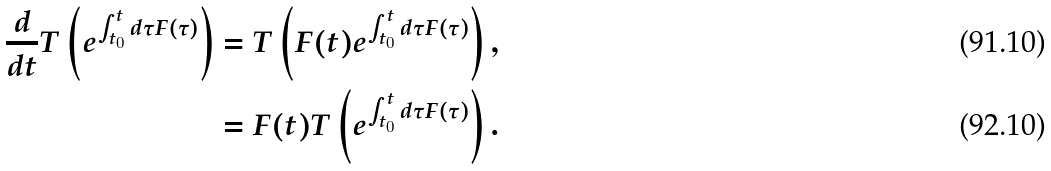Convert formula to latex. <formula><loc_0><loc_0><loc_500><loc_500>\frac { d } { d t } T \left ( e ^ { \int _ { t _ { 0 } } ^ { t } d \tau F ( \tau ) } \right ) & = T \left ( F ( t ) e ^ { \int _ { t _ { 0 } } ^ { t } d \tau F ( \tau ) } \right ) , \\ & = F ( t ) T \left ( e ^ { \int _ { t _ { 0 } } ^ { t } d \tau F ( \tau ) } \right ) .</formula> 